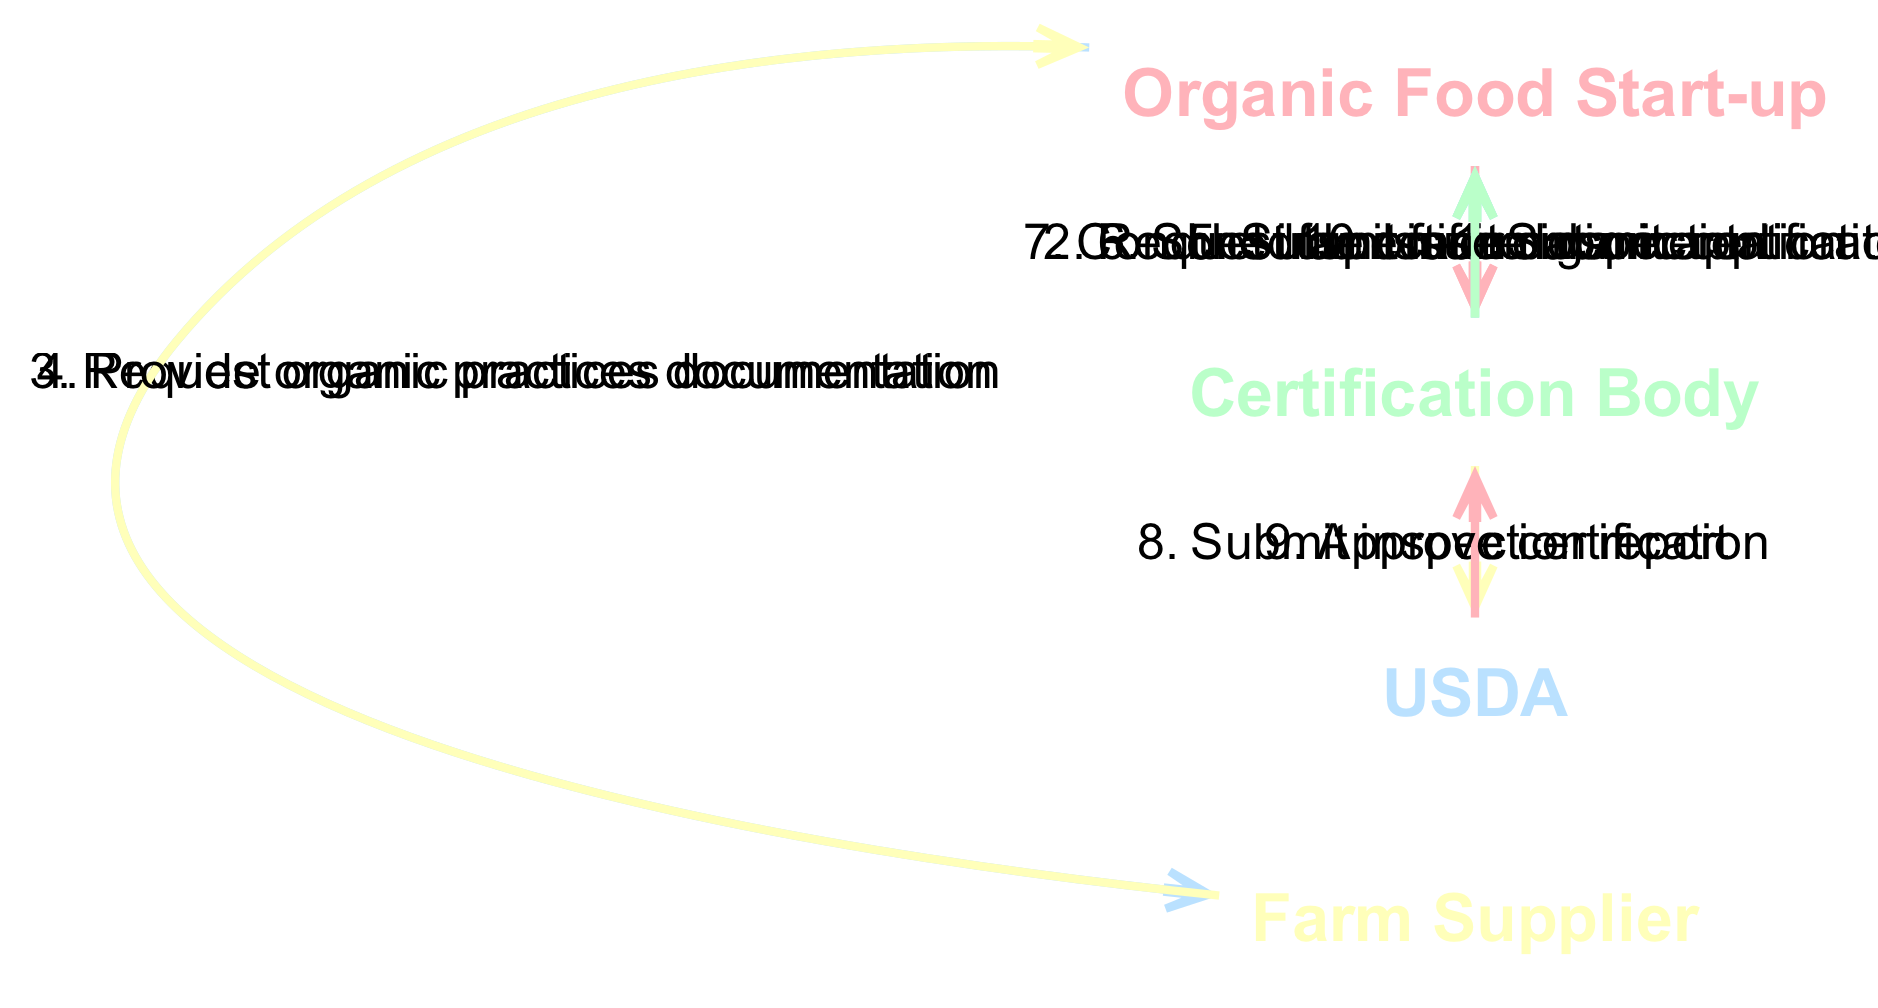What is the first action in the sequence? The first action listed in the sequence is "Submit application," which occurs from the Organic Food Start-up to the Certification Body.
Answer: Submit application Who conducts the on-site inspection? According to the diagram, the action "Conduct inspection" is performed by the Certification Body.
Answer: Certification Body How many total actions are present in the sequence? By counting the number of actions listed in the sequence, there are a total of ten distinct actions.
Answer: 10 What documentation does the Organic Food Start-up request from the Farm Supplier? The Organic Food Start-up requests "organic practices documentation" from the Farm Supplier.
Answer: organic practices documentation What is the final action performed in the sequence? The last action enumerated in the sequence is "Issue organic certificate," which involves the Certification Body and concludes the certification process.
Answer: Issue organic certificate Which two actors are involved in submitting documents? The sequence reveals that the Organic Food Start-up submits both the "application" and "farm documentation" to the Certification Body.
Answer: Organic Food Start-up, Certification Body What does the USDA do after receiving the inspection report? After receiving the "Submit inspection report" action from the Certification Body, the USDA proceeds to "Approve certification."
Answer: Approve certification What is the relationship between the Certification Body and the USDA? The Certification Body submits an inspection report to the USDA, which then approves or disapproves the certification based on that report.
Answer: Submit inspection report Which action directly follows the request for farm information? The action that comes after "Request farm information" is "Request organic practices documentation," indicating the Organic Food Start-up's next step.
Answer: Request organic practices documentation 